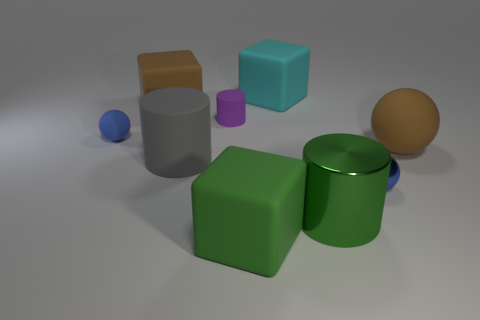Subtract all blocks. How many objects are left? 6 Add 1 small blue metallic spheres. How many small blue metallic spheres exist? 2 Subtract 1 purple cylinders. How many objects are left? 8 Subtract all big green objects. Subtract all big cylinders. How many objects are left? 5 Add 8 green cubes. How many green cubes are left? 9 